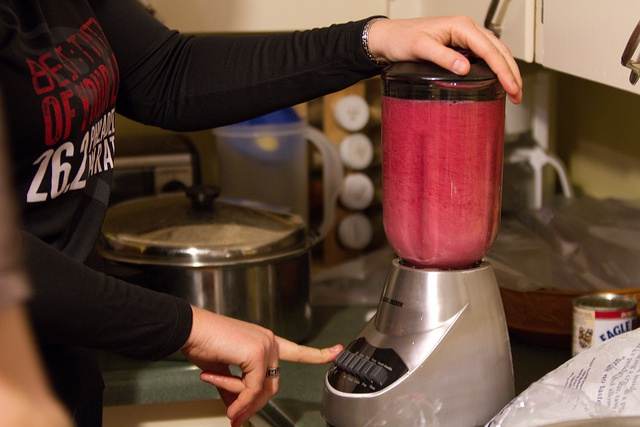Describe the objects in this image and their specific colors. I can see people in black, tan, maroon, and salmon tones and bowl in black, maroon, and gray tones in this image. 